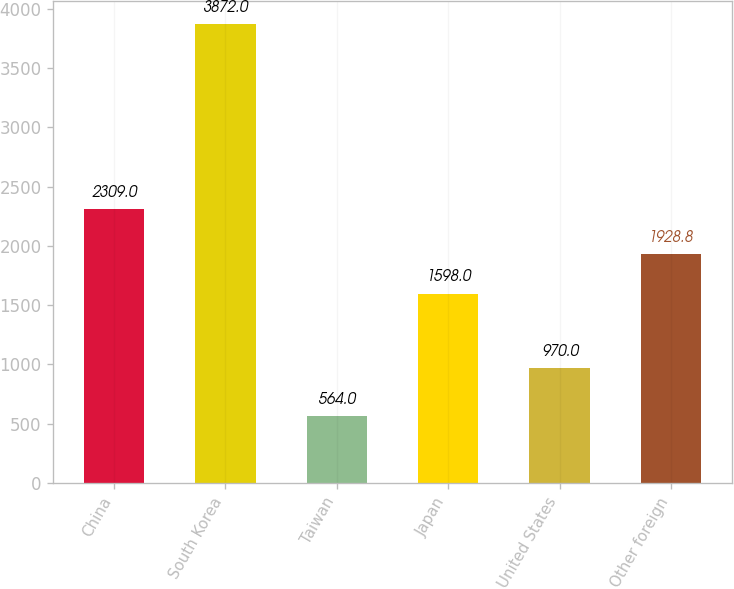Convert chart. <chart><loc_0><loc_0><loc_500><loc_500><bar_chart><fcel>China<fcel>South Korea<fcel>Taiwan<fcel>Japan<fcel>United States<fcel>Other foreign<nl><fcel>2309<fcel>3872<fcel>564<fcel>1598<fcel>970<fcel>1928.8<nl></chart> 